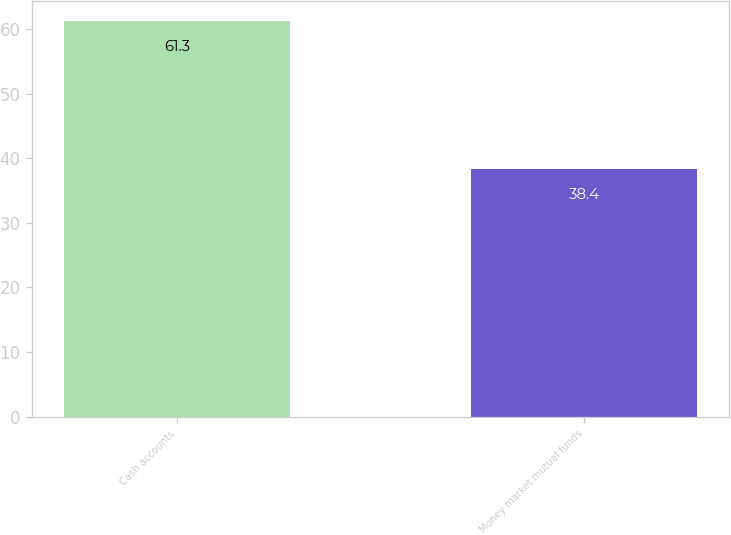Convert chart. <chart><loc_0><loc_0><loc_500><loc_500><bar_chart><fcel>Cash accounts<fcel>Money market mutual funds<nl><fcel>61.3<fcel>38.4<nl></chart> 